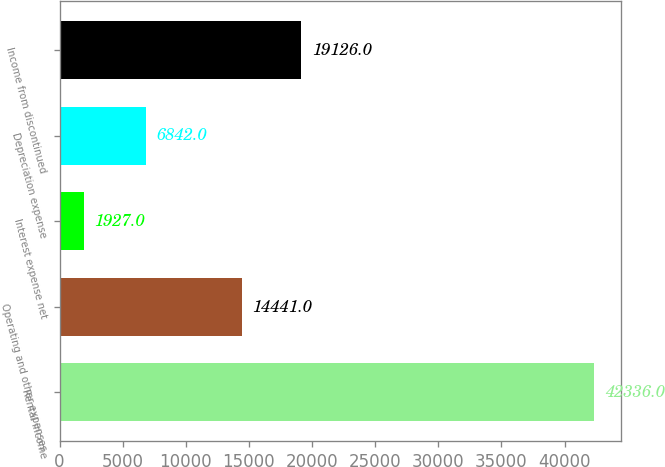Convert chart to OTSL. <chart><loc_0><loc_0><loc_500><loc_500><bar_chart><fcel>Rental income<fcel>Operating and other expenses<fcel>Interest expense net<fcel>Depreciation expense<fcel>Income from discontinued<nl><fcel>42336<fcel>14441<fcel>1927<fcel>6842<fcel>19126<nl></chart> 